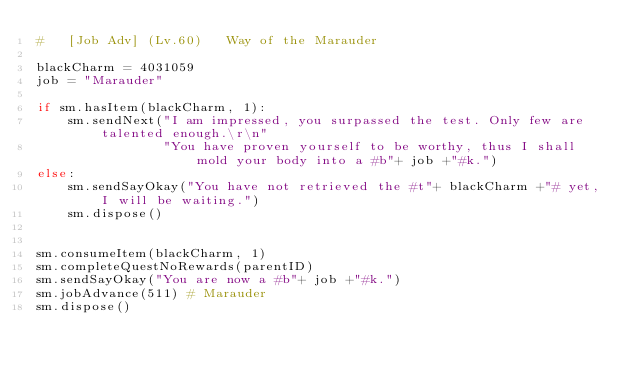<code> <loc_0><loc_0><loc_500><loc_500><_Python_>#   [Job Adv] (Lv.60)   Way of the Marauder

blackCharm = 4031059
job = "Marauder"

if sm.hasItem(blackCharm, 1):
    sm.sendNext("I am impressed, you surpassed the test. Only few are talented enough.\r\n"
                "You have proven yourself to be worthy, thus I shall mold your body into a #b"+ job +"#k.")
else:
    sm.sendSayOkay("You have not retrieved the #t"+ blackCharm +"# yet, I will be waiting.")
    sm.dispose()


sm.consumeItem(blackCharm, 1)
sm.completeQuestNoRewards(parentID)
sm.sendSayOkay("You are now a #b"+ job +"#k.")
sm.jobAdvance(511) # Marauder
sm.dispose()
</code> 